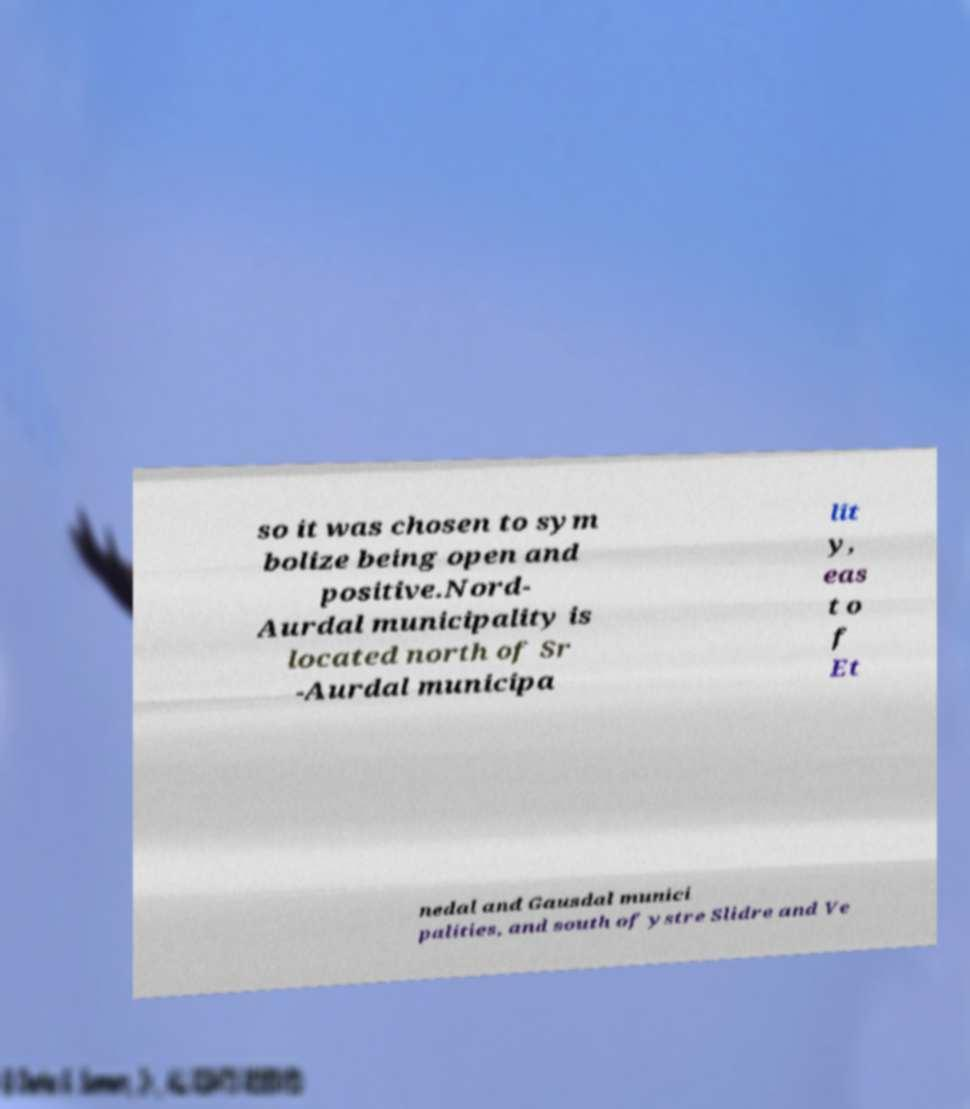For documentation purposes, I need the text within this image transcribed. Could you provide that? so it was chosen to sym bolize being open and positive.Nord- Aurdal municipality is located north of Sr -Aurdal municipa lit y, eas t o f Et nedal and Gausdal munici palities, and south of ystre Slidre and Ve 